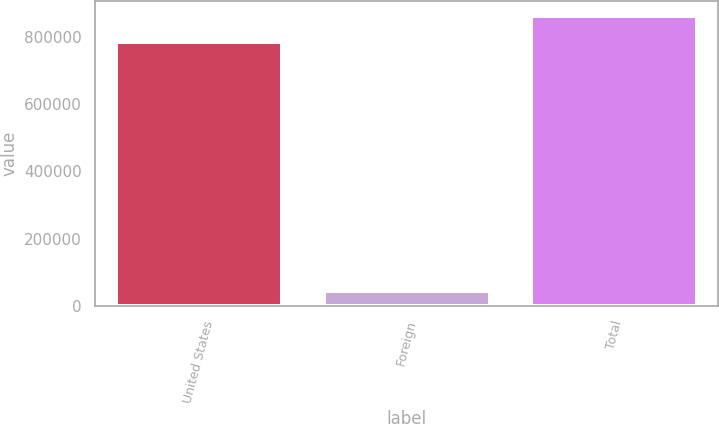<chart> <loc_0><loc_0><loc_500><loc_500><bar_chart><fcel>United States<fcel>Foreign<fcel>Total<nl><fcel>785201<fcel>44761<fcel>863721<nl></chart> 